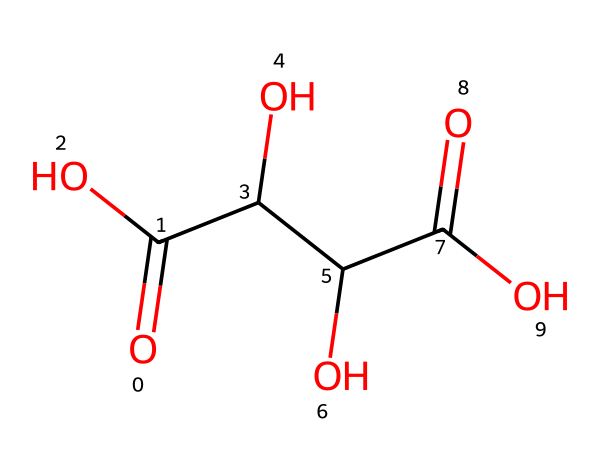How many carbon atoms are in tartaric acid? The molecular formula's composition can be deduced from the structure. In the SMILES representation, every 'C' stands for a carbon atom. The structure indicates four carbon atoms in total, providing the count directly from the representation.
Answer: four What is the molecular formula for tartaric acid? The molecular arrangement can be translated into a conventional molecular formula. Based on the provided SMILES, we identify the atoms present: 4 Carbon (C), 6 Hydrogen (H), and 5 Oxygen (O), leading to the formulation C4H6O6.
Answer: C4H6O6 How many hydroxyl (OH) groups are present in tartaric acid? By examining the structure represented in the SMILES, specifically looking for 'O' atoms bonded to 'H' which are typical in hydroxyl groups, we find two distinct pairs in the structure.
Answer: two What functional groups are present in tartaric acid? The structure reveals two types of functional groups: carboxylic acid (indicated by the presence of the carboxyl groups -COOH) and hydroxyl groups (-OH). The labeled structure allows for identification of these functional groups directly.
Answer: carboxylic acid, hydroxyl Which property of tartaric acid contributes to wine acidity? The presence of the carboxylic acid functional groups (-COOH) in the structure means that the substance can donate protons, thereby increasing the acidity. Thus, recognizing these groups provides insight into its role in wine acidity.
Answer: carboxylic acid 